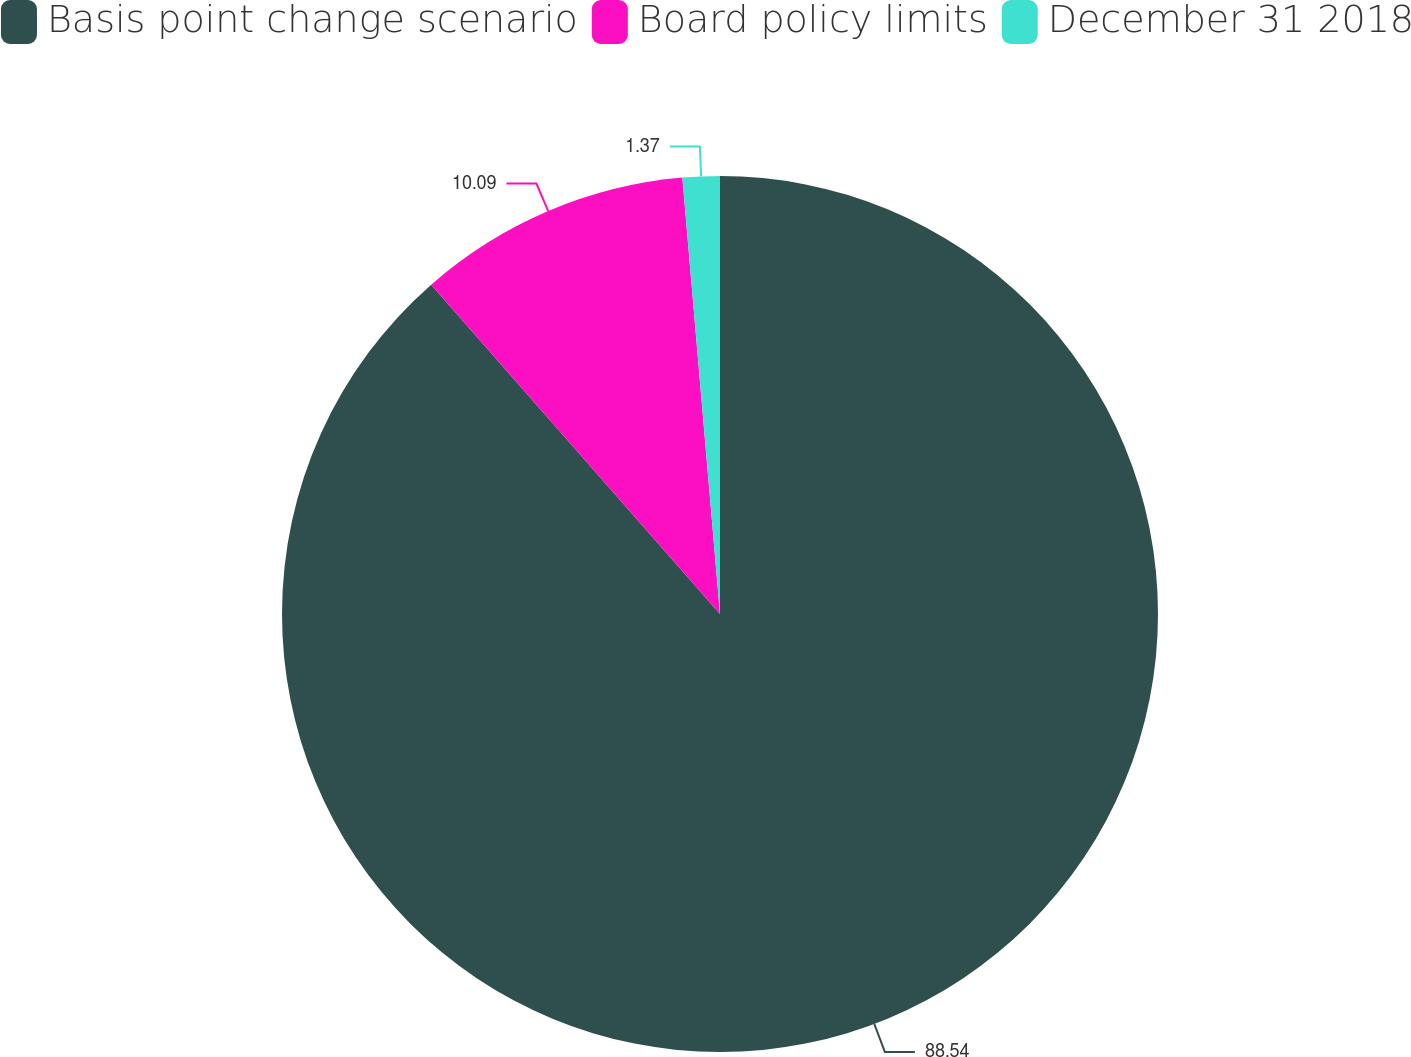Convert chart to OTSL. <chart><loc_0><loc_0><loc_500><loc_500><pie_chart><fcel>Basis point change scenario<fcel>Board policy limits<fcel>December 31 2018<nl><fcel>88.54%<fcel>10.09%<fcel>1.37%<nl></chart> 